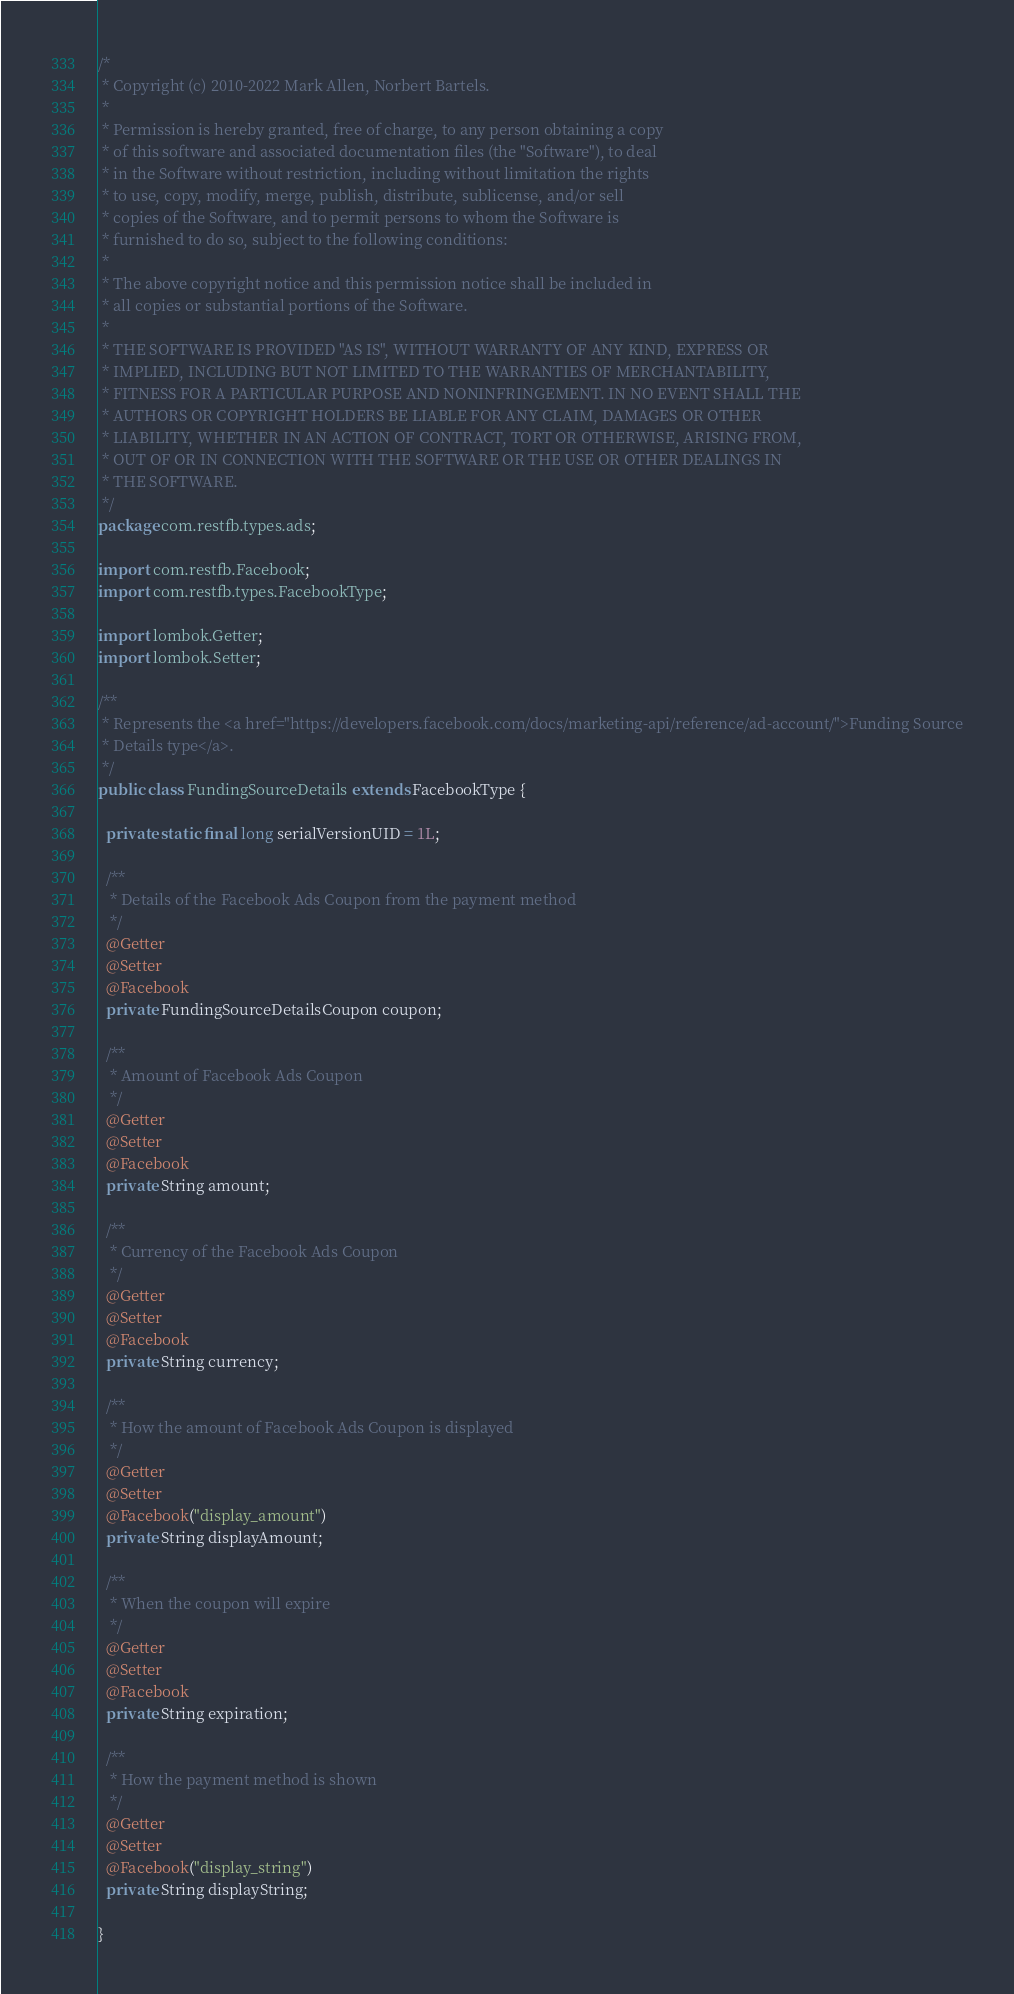Convert code to text. <code><loc_0><loc_0><loc_500><loc_500><_Java_>/*
 * Copyright (c) 2010-2022 Mark Allen, Norbert Bartels.
 *
 * Permission is hereby granted, free of charge, to any person obtaining a copy
 * of this software and associated documentation files (the "Software"), to deal
 * in the Software without restriction, including without limitation the rights
 * to use, copy, modify, merge, publish, distribute, sublicense, and/or sell
 * copies of the Software, and to permit persons to whom the Software is
 * furnished to do so, subject to the following conditions:
 *
 * The above copyright notice and this permission notice shall be included in
 * all copies or substantial portions of the Software.
 *
 * THE SOFTWARE IS PROVIDED "AS IS", WITHOUT WARRANTY OF ANY KIND, EXPRESS OR
 * IMPLIED, INCLUDING BUT NOT LIMITED TO THE WARRANTIES OF MERCHANTABILITY,
 * FITNESS FOR A PARTICULAR PURPOSE AND NONINFRINGEMENT. IN NO EVENT SHALL THE
 * AUTHORS OR COPYRIGHT HOLDERS BE LIABLE FOR ANY CLAIM, DAMAGES OR OTHER
 * LIABILITY, WHETHER IN AN ACTION OF CONTRACT, TORT OR OTHERWISE, ARISING FROM,
 * OUT OF OR IN CONNECTION WITH THE SOFTWARE OR THE USE OR OTHER DEALINGS IN
 * THE SOFTWARE.
 */
package com.restfb.types.ads;

import com.restfb.Facebook;
import com.restfb.types.FacebookType;

import lombok.Getter;
import lombok.Setter;

/**
 * Represents the <a href="https://developers.facebook.com/docs/marketing-api/reference/ad-account/">Funding Source
 * Details type</a>.
 */
public class FundingSourceDetails extends FacebookType {

  private static final long serialVersionUID = 1L;

  /**
   * Details of the Facebook Ads Coupon from the payment method
   */
  @Getter
  @Setter
  @Facebook
  private FundingSourceDetailsCoupon coupon;

  /**
   * Amount of Facebook Ads Coupon
   */
  @Getter
  @Setter
  @Facebook
  private String amount;

  /**
   * Currency of the Facebook Ads Coupon
   */
  @Getter
  @Setter
  @Facebook
  private String currency;

  /**
   * How the amount of Facebook Ads Coupon is displayed
   */
  @Getter
  @Setter
  @Facebook("display_amount")
  private String displayAmount;

  /**
   * When the coupon will expire
   */
  @Getter
  @Setter
  @Facebook
  private String expiration;

  /**
   * How the payment method is shown
   */
  @Getter
  @Setter
  @Facebook("display_string")
  private String displayString;

}
</code> 